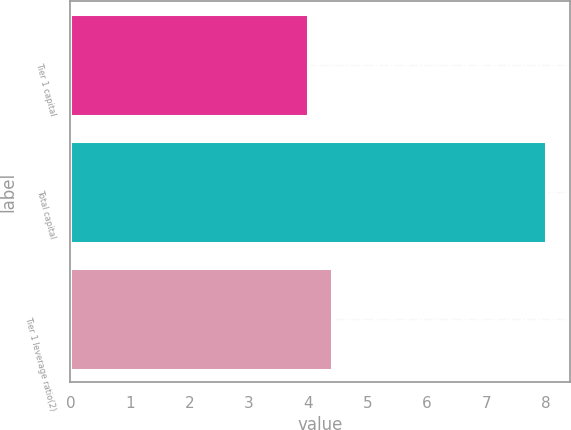Convert chart to OTSL. <chart><loc_0><loc_0><loc_500><loc_500><bar_chart><fcel>Tier 1 capital<fcel>Total capital<fcel>Tier 1 leverage ratio(2)<nl><fcel>4<fcel>8<fcel>4.4<nl></chart> 